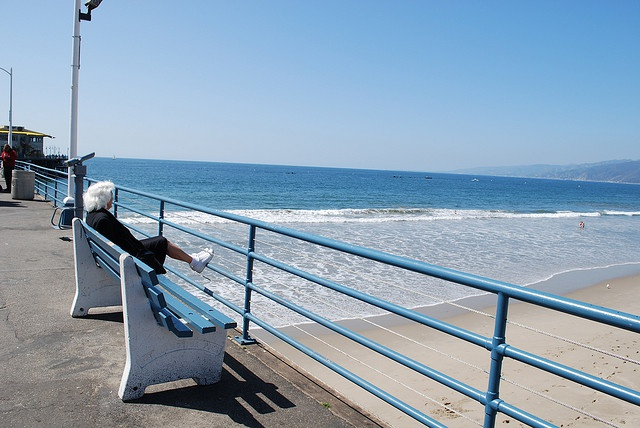Describe the objects in this image and their specific colors. I can see bench in lightblue, gray, black, and blue tones, people in lightblue, black, lightgray, darkgray, and gray tones, people in lightblue, black, maroon, brown, and gray tones, and people in lightblue, darkgray, brown, and gray tones in this image. 